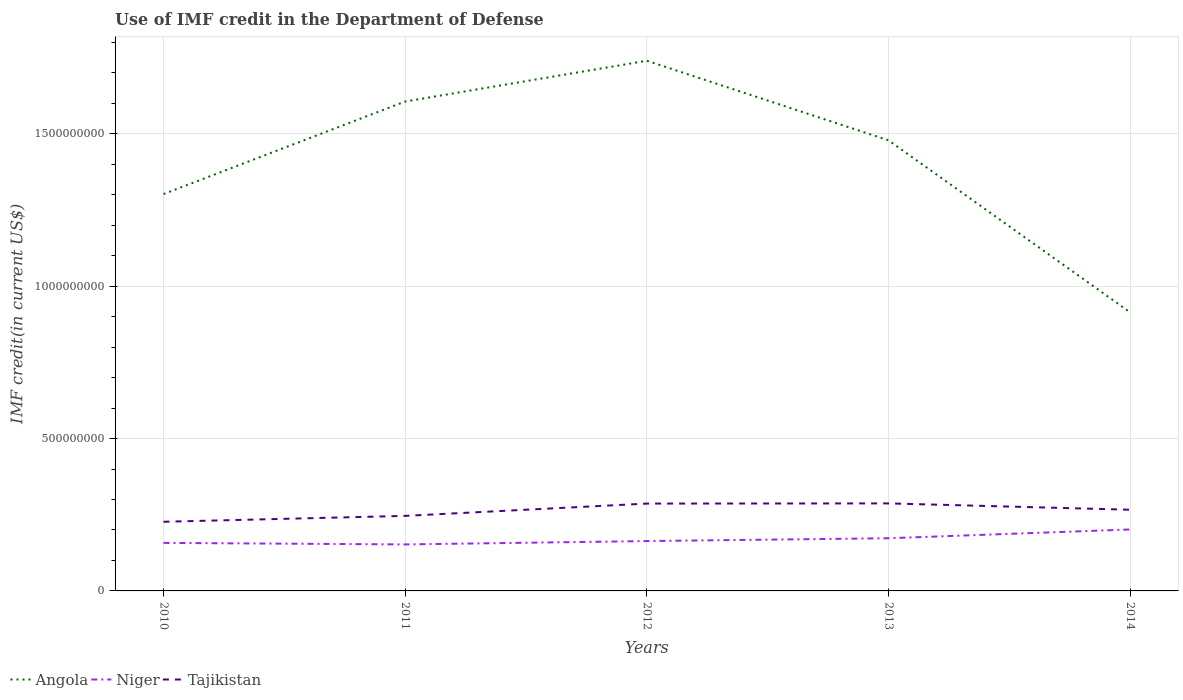Does the line corresponding to Tajikistan intersect with the line corresponding to Angola?
Your answer should be compact. No. Is the number of lines equal to the number of legend labels?
Ensure brevity in your answer.  Yes. Across all years, what is the maximum IMF credit in the Department of Defense in Tajikistan?
Ensure brevity in your answer.  2.27e+08. What is the total IMF credit in the Department of Defense in Niger in the graph?
Your response must be concise. -2.03e+07. What is the difference between the highest and the second highest IMF credit in the Department of Defense in Tajikistan?
Provide a succinct answer. 6.03e+07. What is the difference between the highest and the lowest IMF credit in the Department of Defense in Tajikistan?
Keep it short and to the point. 3. Is the IMF credit in the Department of Defense in Niger strictly greater than the IMF credit in the Department of Defense in Angola over the years?
Make the answer very short. Yes. How many lines are there?
Your answer should be compact. 3. How many years are there in the graph?
Offer a terse response. 5. What is the difference between two consecutive major ticks on the Y-axis?
Your answer should be very brief. 5.00e+08. Are the values on the major ticks of Y-axis written in scientific E-notation?
Provide a succinct answer. No. Does the graph contain any zero values?
Make the answer very short. No. Does the graph contain grids?
Offer a very short reply. Yes. Where does the legend appear in the graph?
Offer a very short reply. Bottom left. How many legend labels are there?
Keep it short and to the point. 3. What is the title of the graph?
Keep it short and to the point. Use of IMF credit in the Department of Defense. Does "Low income" appear as one of the legend labels in the graph?
Offer a very short reply. No. What is the label or title of the Y-axis?
Give a very brief answer. IMF credit(in current US$). What is the IMF credit(in current US$) of Angola in 2010?
Your answer should be very brief. 1.30e+09. What is the IMF credit(in current US$) of Niger in 2010?
Your response must be concise. 1.58e+08. What is the IMF credit(in current US$) of Tajikistan in 2010?
Make the answer very short. 2.27e+08. What is the IMF credit(in current US$) in Angola in 2011?
Provide a short and direct response. 1.61e+09. What is the IMF credit(in current US$) of Niger in 2011?
Offer a very short reply. 1.53e+08. What is the IMF credit(in current US$) of Tajikistan in 2011?
Give a very brief answer. 2.46e+08. What is the IMF credit(in current US$) in Angola in 2012?
Provide a short and direct response. 1.74e+09. What is the IMF credit(in current US$) of Niger in 2012?
Provide a succinct answer. 1.64e+08. What is the IMF credit(in current US$) in Tajikistan in 2012?
Provide a succinct answer. 2.87e+08. What is the IMF credit(in current US$) of Angola in 2013?
Keep it short and to the point. 1.48e+09. What is the IMF credit(in current US$) of Niger in 2013?
Your response must be concise. 1.73e+08. What is the IMF credit(in current US$) in Tajikistan in 2013?
Your response must be concise. 2.87e+08. What is the IMF credit(in current US$) in Angola in 2014?
Your answer should be very brief. 9.14e+08. What is the IMF credit(in current US$) in Niger in 2014?
Give a very brief answer. 2.02e+08. What is the IMF credit(in current US$) of Tajikistan in 2014?
Give a very brief answer. 2.66e+08. Across all years, what is the maximum IMF credit(in current US$) of Angola?
Provide a short and direct response. 1.74e+09. Across all years, what is the maximum IMF credit(in current US$) of Niger?
Offer a very short reply. 2.02e+08. Across all years, what is the maximum IMF credit(in current US$) of Tajikistan?
Your answer should be very brief. 2.87e+08. Across all years, what is the minimum IMF credit(in current US$) in Angola?
Make the answer very short. 9.14e+08. Across all years, what is the minimum IMF credit(in current US$) in Niger?
Provide a short and direct response. 1.53e+08. Across all years, what is the minimum IMF credit(in current US$) in Tajikistan?
Your answer should be compact. 2.27e+08. What is the total IMF credit(in current US$) in Angola in the graph?
Offer a very short reply. 7.04e+09. What is the total IMF credit(in current US$) in Niger in the graph?
Give a very brief answer. 8.48e+08. What is the total IMF credit(in current US$) in Tajikistan in the graph?
Your answer should be very brief. 1.31e+09. What is the difference between the IMF credit(in current US$) of Angola in 2010 and that in 2011?
Your response must be concise. -3.04e+08. What is the difference between the IMF credit(in current US$) of Niger in 2010 and that in 2011?
Your answer should be very brief. 5.00e+06. What is the difference between the IMF credit(in current US$) in Tajikistan in 2010 and that in 2011?
Provide a succinct answer. -1.93e+07. What is the difference between the IMF credit(in current US$) in Angola in 2010 and that in 2012?
Provide a short and direct response. -4.37e+08. What is the difference between the IMF credit(in current US$) of Niger in 2010 and that in 2012?
Give a very brief answer. -6.04e+06. What is the difference between the IMF credit(in current US$) of Tajikistan in 2010 and that in 2012?
Your answer should be compact. -5.97e+07. What is the difference between the IMF credit(in current US$) in Angola in 2010 and that in 2013?
Give a very brief answer. -1.76e+08. What is the difference between the IMF credit(in current US$) in Niger in 2010 and that in 2013?
Offer a very short reply. -1.53e+07. What is the difference between the IMF credit(in current US$) of Tajikistan in 2010 and that in 2013?
Provide a succinct answer. -6.03e+07. What is the difference between the IMF credit(in current US$) of Angola in 2010 and that in 2014?
Give a very brief answer. 3.88e+08. What is the difference between the IMF credit(in current US$) in Niger in 2010 and that in 2014?
Ensure brevity in your answer.  -4.41e+07. What is the difference between the IMF credit(in current US$) of Tajikistan in 2010 and that in 2014?
Give a very brief answer. -3.95e+07. What is the difference between the IMF credit(in current US$) of Angola in 2011 and that in 2012?
Make the answer very short. -1.34e+08. What is the difference between the IMF credit(in current US$) of Niger in 2011 and that in 2012?
Keep it short and to the point. -1.10e+07. What is the difference between the IMF credit(in current US$) of Tajikistan in 2011 and that in 2012?
Your response must be concise. -4.04e+07. What is the difference between the IMF credit(in current US$) in Angola in 2011 and that in 2013?
Give a very brief answer. 1.27e+08. What is the difference between the IMF credit(in current US$) of Niger in 2011 and that in 2013?
Your answer should be compact. -2.03e+07. What is the difference between the IMF credit(in current US$) in Tajikistan in 2011 and that in 2013?
Offer a very short reply. -4.09e+07. What is the difference between the IMF credit(in current US$) in Angola in 2011 and that in 2014?
Offer a very short reply. 6.92e+08. What is the difference between the IMF credit(in current US$) in Niger in 2011 and that in 2014?
Keep it short and to the point. -4.90e+07. What is the difference between the IMF credit(in current US$) of Tajikistan in 2011 and that in 2014?
Offer a very short reply. -2.02e+07. What is the difference between the IMF credit(in current US$) of Angola in 2012 and that in 2013?
Offer a very short reply. 2.61e+08. What is the difference between the IMF credit(in current US$) in Niger in 2012 and that in 2013?
Offer a very short reply. -9.23e+06. What is the difference between the IMF credit(in current US$) in Tajikistan in 2012 and that in 2013?
Your response must be concise. -5.74e+05. What is the difference between the IMF credit(in current US$) of Angola in 2012 and that in 2014?
Make the answer very short. 8.26e+08. What is the difference between the IMF credit(in current US$) of Niger in 2012 and that in 2014?
Offer a very short reply. -3.80e+07. What is the difference between the IMF credit(in current US$) of Tajikistan in 2012 and that in 2014?
Offer a very short reply. 2.02e+07. What is the difference between the IMF credit(in current US$) of Angola in 2013 and that in 2014?
Provide a succinct answer. 5.65e+08. What is the difference between the IMF credit(in current US$) in Niger in 2013 and that in 2014?
Ensure brevity in your answer.  -2.88e+07. What is the difference between the IMF credit(in current US$) of Tajikistan in 2013 and that in 2014?
Make the answer very short. 2.08e+07. What is the difference between the IMF credit(in current US$) in Angola in 2010 and the IMF credit(in current US$) in Niger in 2011?
Offer a very short reply. 1.15e+09. What is the difference between the IMF credit(in current US$) in Angola in 2010 and the IMF credit(in current US$) in Tajikistan in 2011?
Offer a very short reply. 1.06e+09. What is the difference between the IMF credit(in current US$) of Niger in 2010 and the IMF credit(in current US$) of Tajikistan in 2011?
Keep it short and to the point. -8.87e+07. What is the difference between the IMF credit(in current US$) in Angola in 2010 and the IMF credit(in current US$) in Niger in 2012?
Offer a terse response. 1.14e+09. What is the difference between the IMF credit(in current US$) in Angola in 2010 and the IMF credit(in current US$) in Tajikistan in 2012?
Give a very brief answer. 1.02e+09. What is the difference between the IMF credit(in current US$) in Niger in 2010 and the IMF credit(in current US$) in Tajikistan in 2012?
Make the answer very short. -1.29e+08. What is the difference between the IMF credit(in current US$) in Angola in 2010 and the IMF credit(in current US$) in Niger in 2013?
Your answer should be very brief. 1.13e+09. What is the difference between the IMF credit(in current US$) in Angola in 2010 and the IMF credit(in current US$) in Tajikistan in 2013?
Your answer should be very brief. 1.02e+09. What is the difference between the IMF credit(in current US$) in Niger in 2010 and the IMF credit(in current US$) in Tajikistan in 2013?
Keep it short and to the point. -1.30e+08. What is the difference between the IMF credit(in current US$) of Angola in 2010 and the IMF credit(in current US$) of Niger in 2014?
Offer a very short reply. 1.10e+09. What is the difference between the IMF credit(in current US$) in Angola in 2010 and the IMF credit(in current US$) in Tajikistan in 2014?
Keep it short and to the point. 1.04e+09. What is the difference between the IMF credit(in current US$) of Niger in 2010 and the IMF credit(in current US$) of Tajikistan in 2014?
Offer a very short reply. -1.09e+08. What is the difference between the IMF credit(in current US$) in Angola in 2011 and the IMF credit(in current US$) in Niger in 2012?
Your response must be concise. 1.44e+09. What is the difference between the IMF credit(in current US$) in Angola in 2011 and the IMF credit(in current US$) in Tajikistan in 2012?
Give a very brief answer. 1.32e+09. What is the difference between the IMF credit(in current US$) of Niger in 2011 and the IMF credit(in current US$) of Tajikistan in 2012?
Make the answer very short. -1.34e+08. What is the difference between the IMF credit(in current US$) of Angola in 2011 and the IMF credit(in current US$) of Niger in 2013?
Give a very brief answer. 1.43e+09. What is the difference between the IMF credit(in current US$) in Angola in 2011 and the IMF credit(in current US$) in Tajikistan in 2013?
Offer a terse response. 1.32e+09. What is the difference between the IMF credit(in current US$) of Niger in 2011 and the IMF credit(in current US$) of Tajikistan in 2013?
Your response must be concise. -1.35e+08. What is the difference between the IMF credit(in current US$) of Angola in 2011 and the IMF credit(in current US$) of Niger in 2014?
Offer a very short reply. 1.40e+09. What is the difference between the IMF credit(in current US$) in Angola in 2011 and the IMF credit(in current US$) in Tajikistan in 2014?
Keep it short and to the point. 1.34e+09. What is the difference between the IMF credit(in current US$) of Niger in 2011 and the IMF credit(in current US$) of Tajikistan in 2014?
Your response must be concise. -1.14e+08. What is the difference between the IMF credit(in current US$) in Angola in 2012 and the IMF credit(in current US$) in Niger in 2013?
Provide a succinct answer. 1.57e+09. What is the difference between the IMF credit(in current US$) of Angola in 2012 and the IMF credit(in current US$) of Tajikistan in 2013?
Provide a succinct answer. 1.45e+09. What is the difference between the IMF credit(in current US$) in Niger in 2012 and the IMF credit(in current US$) in Tajikistan in 2013?
Your answer should be very brief. -1.24e+08. What is the difference between the IMF credit(in current US$) of Angola in 2012 and the IMF credit(in current US$) of Niger in 2014?
Your answer should be very brief. 1.54e+09. What is the difference between the IMF credit(in current US$) in Angola in 2012 and the IMF credit(in current US$) in Tajikistan in 2014?
Ensure brevity in your answer.  1.47e+09. What is the difference between the IMF credit(in current US$) of Niger in 2012 and the IMF credit(in current US$) of Tajikistan in 2014?
Your answer should be very brief. -1.03e+08. What is the difference between the IMF credit(in current US$) of Angola in 2013 and the IMF credit(in current US$) of Niger in 2014?
Provide a short and direct response. 1.28e+09. What is the difference between the IMF credit(in current US$) of Angola in 2013 and the IMF credit(in current US$) of Tajikistan in 2014?
Keep it short and to the point. 1.21e+09. What is the difference between the IMF credit(in current US$) in Niger in 2013 and the IMF credit(in current US$) in Tajikistan in 2014?
Offer a terse response. -9.35e+07. What is the average IMF credit(in current US$) of Angola per year?
Keep it short and to the point. 1.41e+09. What is the average IMF credit(in current US$) of Niger per year?
Provide a short and direct response. 1.70e+08. What is the average IMF credit(in current US$) in Tajikistan per year?
Offer a terse response. 2.63e+08. In the year 2010, what is the difference between the IMF credit(in current US$) in Angola and IMF credit(in current US$) in Niger?
Your response must be concise. 1.14e+09. In the year 2010, what is the difference between the IMF credit(in current US$) in Angola and IMF credit(in current US$) in Tajikistan?
Offer a terse response. 1.08e+09. In the year 2010, what is the difference between the IMF credit(in current US$) in Niger and IMF credit(in current US$) in Tajikistan?
Provide a short and direct response. -6.93e+07. In the year 2011, what is the difference between the IMF credit(in current US$) in Angola and IMF credit(in current US$) in Niger?
Your answer should be compact. 1.45e+09. In the year 2011, what is the difference between the IMF credit(in current US$) of Angola and IMF credit(in current US$) of Tajikistan?
Provide a succinct answer. 1.36e+09. In the year 2011, what is the difference between the IMF credit(in current US$) in Niger and IMF credit(in current US$) in Tajikistan?
Make the answer very short. -9.37e+07. In the year 2012, what is the difference between the IMF credit(in current US$) of Angola and IMF credit(in current US$) of Niger?
Your answer should be very brief. 1.58e+09. In the year 2012, what is the difference between the IMF credit(in current US$) in Angola and IMF credit(in current US$) in Tajikistan?
Offer a very short reply. 1.45e+09. In the year 2012, what is the difference between the IMF credit(in current US$) in Niger and IMF credit(in current US$) in Tajikistan?
Your answer should be compact. -1.23e+08. In the year 2013, what is the difference between the IMF credit(in current US$) in Angola and IMF credit(in current US$) in Niger?
Provide a short and direct response. 1.31e+09. In the year 2013, what is the difference between the IMF credit(in current US$) of Angola and IMF credit(in current US$) of Tajikistan?
Provide a short and direct response. 1.19e+09. In the year 2013, what is the difference between the IMF credit(in current US$) of Niger and IMF credit(in current US$) of Tajikistan?
Keep it short and to the point. -1.14e+08. In the year 2014, what is the difference between the IMF credit(in current US$) in Angola and IMF credit(in current US$) in Niger?
Your response must be concise. 7.12e+08. In the year 2014, what is the difference between the IMF credit(in current US$) in Angola and IMF credit(in current US$) in Tajikistan?
Your response must be concise. 6.48e+08. In the year 2014, what is the difference between the IMF credit(in current US$) in Niger and IMF credit(in current US$) in Tajikistan?
Your answer should be compact. -6.48e+07. What is the ratio of the IMF credit(in current US$) in Angola in 2010 to that in 2011?
Provide a succinct answer. 0.81. What is the ratio of the IMF credit(in current US$) of Niger in 2010 to that in 2011?
Offer a terse response. 1.03. What is the ratio of the IMF credit(in current US$) in Tajikistan in 2010 to that in 2011?
Provide a short and direct response. 0.92. What is the ratio of the IMF credit(in current US$) of Angola in 2010 to that in 2012?
Your response must be concise. 0.75. What is the ratio of the IMF credit(in current US$) of Niger in 2010 to that in 2012?
Offer a very short reply. 0.96. What is the ratio of the IMF credit(in current US$) of Tajikistan in 2010 to that in 2012?
Your answer should be compact. 0.79. What is the ratio of the IMF credit(in current US$) of Angola in 2010 to that in 2013?
Offer a very short reply. 0.88. What is the ratio of the IMF credit(in current US$) in Niger in 2010 to that in 2013?
Provide a short and direct response. 0.91. What is the ratio of the IMF credit(in current US$) of Tajikistan in 2010 to that in 2013?
Your response must be concise. 0.79. What is the ratio of the IMF credit(in current US$) of Angola in 2010 to that in 2014?
Your answer should be very brief. 1.42. What is the ratio of the IMF credit(in current US$) in Niger in 2010 to that in 2014?
Ensure brevity in your answer.  0.78. What is the ratio of the IMF credit(in current US$) of Tajikistan in 2010 to that in 2014?
Keep it short and to the point. 0.85. What is the ratio of the IMF credit(in current US$) in Niger in 2011 to that in 2012?
Make the answer very short. 0.93. What is the ratio of the IMF credit(in current US$) of Tajikistan in 2011 to that in 2012?
Provide a short and direct response. 0.86. What is the ratio of the IMF credit(in current US$) in Angola in 2011 to that in 2013?
Keep it short and to the point. 1.09. What is the ratio of the IMF credit(in current US$) of Niger in 2011 to that in 2013?
Offer a very short reply. 0.88. What is the ratio of the IMF credit(in current US$) in Tajikistan in 2011 to that in 2013?
Keep it short and to the point. 0.86. What is the ratio of the IMF credit(in current US$) in Angola in 2011 to that in 2014?
Provide a short and direct response. 1.76. What is the ratio of the IMF credit(in current US$) of Niger in 2011 to that in 2014?
Offer a terse response. 0.76. What is the ratio of the IMF credit(in current US$) in Tajikistan in 2011 to that in 2014?
Offer a very short reply. 0.92. What is the ratio of the IMF credit(in current US$) of Angola in 2012 to that in 2013?
Provide a short and direct response. 1.18. What is the ratio of the IMF credit(in current US$) of Niger in 2012 to that in 2013?
Give a very brief answer. 0.95. What is the ratio of the IMF credit(in current US$) in Angola in 2012 to that in 2014?
Your answer should be compact. 1.9. What is the ratio of the IMF credit(in current US$) of Niger in 2012 to that in 2014?
Your answer should be compact. 0.81. What is the ratio of the IMF credit(in current US$) in Tajikistan in 2012 to that in 2014?
Offer a terse response. 1.08. What is the ratio of the IMF credit(in current US$) in Angola in 2013 to that in 2014?
Make the answer very short. 1.62. What is the ratio of the IMF credit(in current US$) in Niger in 2013 to that in 2014?
Your answer should be compact. 0.86. What is the ratio of the IMF credit(in current US$) in Tajikistan in 2013 to that in 2014?
Make the answer very short. 1.08. What is the difference between the highest and the second highest IMF credit(in current US$) of Angola?
Give a very brief answer. 1.34e+08. What is the difference between the highest and the second highest IMF credit(in current US$) of Niger?
Provide a succinct answer. 2.88e+07. What is the difference between the highest and the second highest IMF credit(in current US$) in Tajikistan?
Offer a very short reply. 5.74e+05. What is the difference between the highest and the lowest IMF credit(in current US$) in Angola?
Provide a succinct answer. 8.26e+08. What is the difference between the highest and the lowest IMF credit(in current US$) of Niger?
Offer a terse response. 4.90e+07. What is the difference between the highest and the lowest IMF credit(in current US$) in Tajikistan?
Your response must be concise. 6.03e+07. 